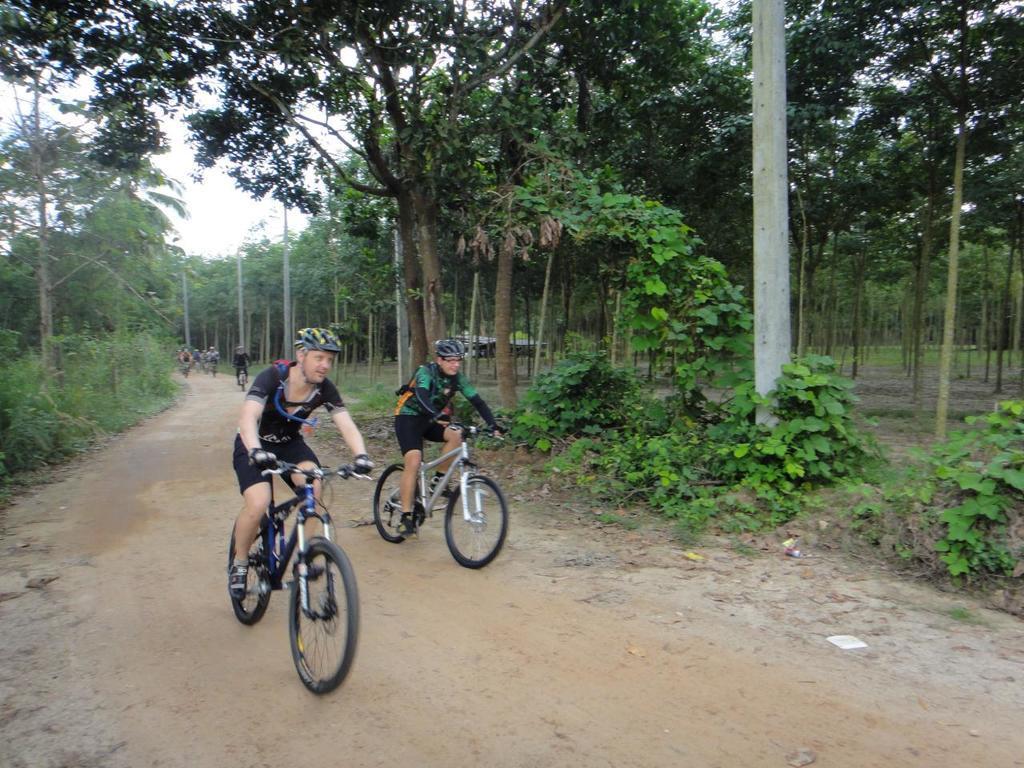Please provide a concise description of this image. In this image there are people cycling on the road. There are plants. In the background of the image there are trees and sky. 